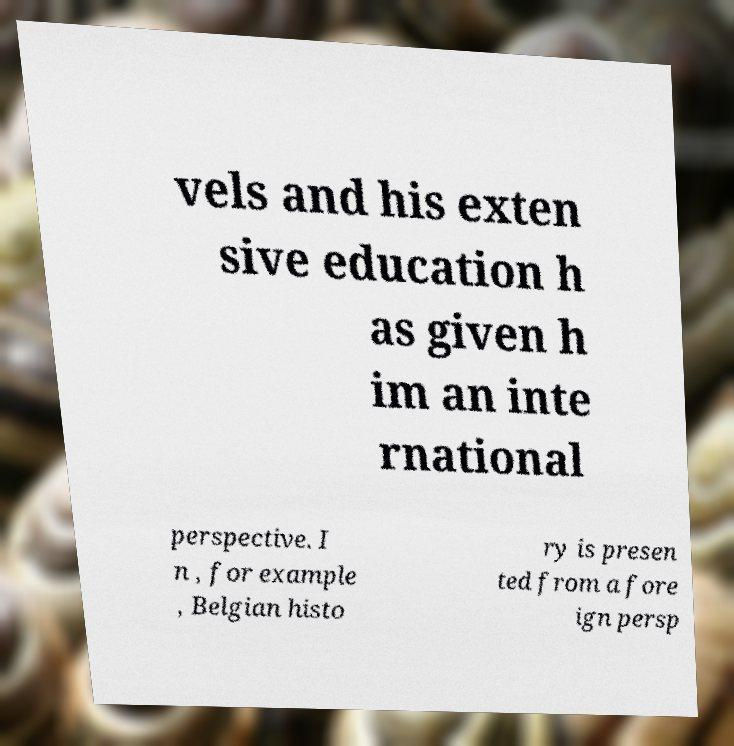I need the written content from this picture converted into text. Can you do that? vels and his exten sive education h as given h im an inte rnational perspective. I n , for example , Belgian histo ry is presen ted from a fore ign persp 